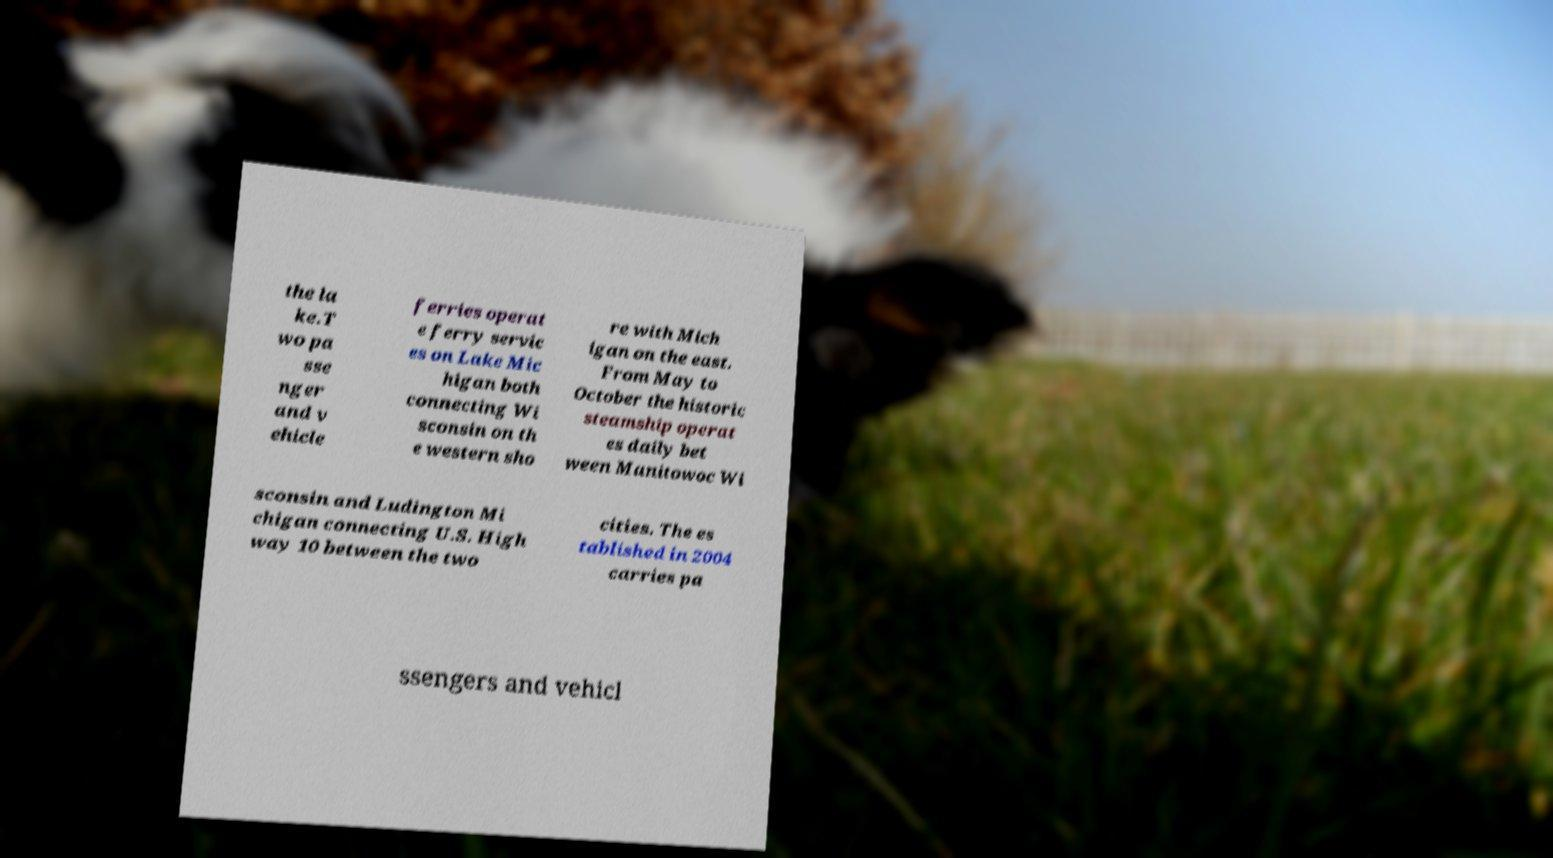What messages or text are displayed in this image? I need them in a readable, typed format. the la ke.T wo pa sse nger and v ehicle ferries operat e ferry servic es on Lake Mic higan both connecting Wi sconsin on th e western sho re with Mich igan on the east. From May to October the historic steamship operat es daily bet ween Manitowoc Wi sconsin and Ludington Mi chigan connecting U.S. High way 10 between the two cities. The es tablished in 2004 carries pa ssengers and vehicl 